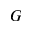Convert formula to latex. <formula><loc_0><loc_0><loc_500><loc_500>G</formula> 